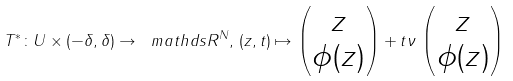<formula> <loc_0><loc_0><loc_500><loc_500>T ^ { \ast } \colon U \times ( - \delta , \delta ) \to \ m a t h d s { R } ^ { N } , \, ( z , t ) \mapsto \begin{pmatrix} z \\ \phi ( z ) \end{pmatrix} + t \nu \, \begin{pmatrix} z \\ \phi ( z ) \end{pmatrix}</formula> 